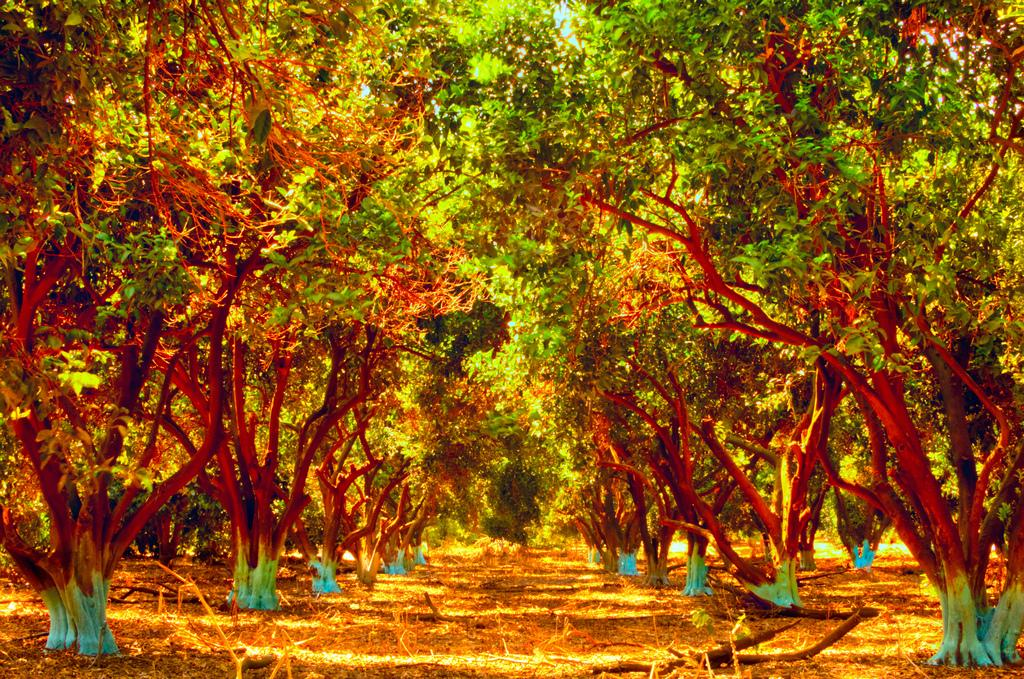What can be seen on the ground in the image? There is a path in the image, and it is covered with dried leaves. What type of vegetation is present in the image? There are trees in the image. How many donkeys can be seen carrying things in the image? There are no donkeys or things being carried in the image; it features a path covered with dried leaves and trees. What type of mice can be seen in the image? There are no mice present in the image. 